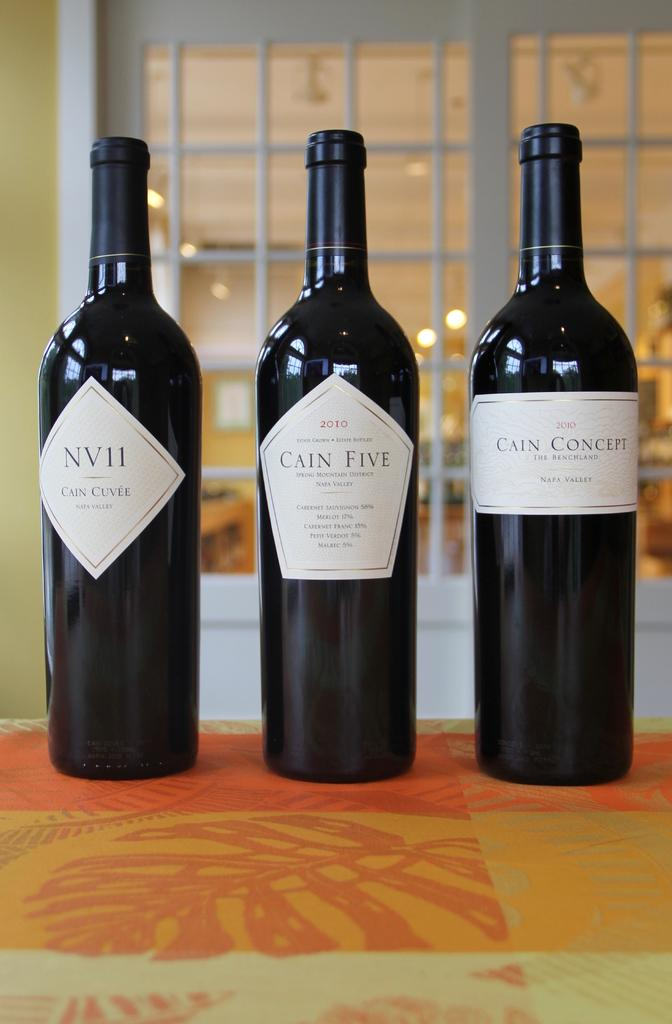<image>
Share a concise interpretation of the image provided. Three bottle of wine one called Cain Five sit on a table. 